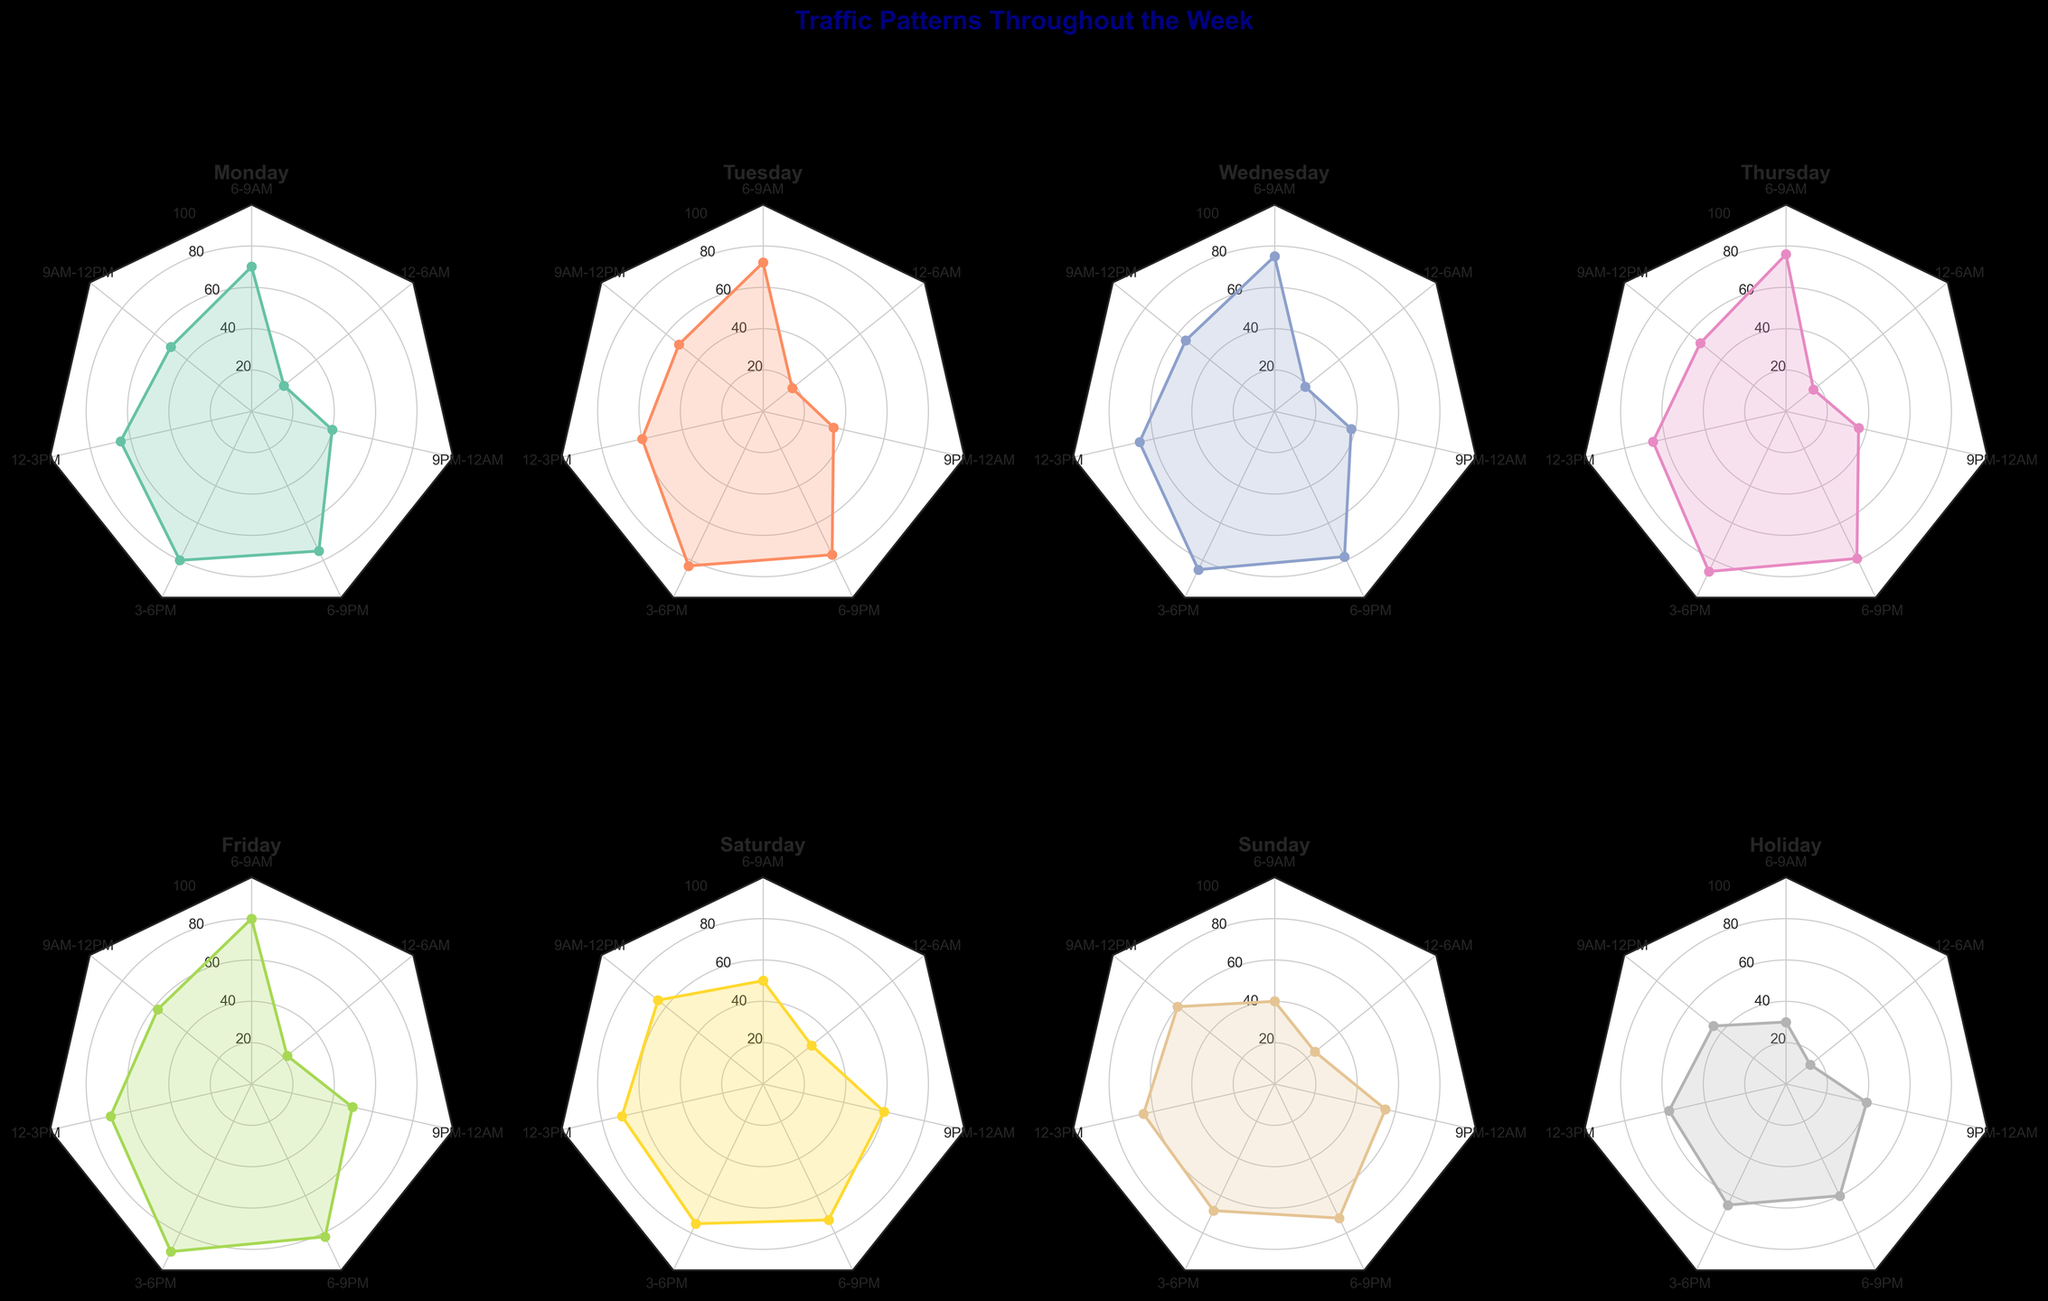What are the time intervals analyzed in the radar charts? The time intervals can be deduced by looking at the axis labels for each of the radar charts. The labels show segments such as 6-9AM, 9AM-12PM, etc.
Answer: 6-9AM, 9AM-12PM, 12-3PM, 3-6PM, 6-9PM, 9PM-12AM, 12-6AM Which day has the highest traffic index during the 3-6PM interval? By examining each subplot, focus on the data point for the 3-6PM interval. The highest peak in this interval appears on the radar chart labeled "Friday."
Answer: Friday On which day is the traffic index lowest during the 12-6AM interval? Look at the 12-6AM segment across all radar charts and find the lowest plotted value. This value occurs on the radar chart labeled "Holiday."
Answer: Holiday Compare the traffic index during peak hours (defined as 6-9AM and 3-6PM) on Wednesday and Saturday. Which day has higher traffic at these intervals? By comparing the marks at 6-9AM and 3-6PM for Wednesday and Saturday, it is evident that Wednesday has higher traffic index values at both intervals.
Answer: Wednesday What is the average traffic index on Sunday during off-peak hours (9PM-12AM and 12-6AM)? To find the average, add the traffic index values for 9PM-12AM (55) and 12-6AM (25) and divide by 2. (55 + 25) / 2 = 40
Answer: 40 How does the traffic pattern on a holiday compare to a typical weekday for the 6-9PM interval? Compare the values at the 6-9PM interval for "Holiday" and any typical weekday (Monday-Friday). The holiday value is 60, while typical weekdays have values like 75, 77, 78, 79, 82, generally higher than on holidays.
Answer: Holidays have lower traffic Which day exhibits the most evenly distributed traffic index across all time intervals? Look for the radar chart with the most balanced shape, meaning the values don't vary drastically across the intervals. It appears that Saturday has the most evenly spread traffic indices.
Answer: Saturday What's the trend in the traffic index from 12-3PM to 9PM-12AM on Tuesday? Check the trend on Tuesday's subplot from the 12-3PM interval (60) to the 9PM-12AM interval (35). The traffic index generally decreases.
Answer: Decreasing trend Identify the day with the highest variability in traffic patterns. Variability can be assessed by looking at the range between the highest and lowest values within a day's subplot. The widest range is observed on Friday, varying from 22 to 90.
Answer: Friday 